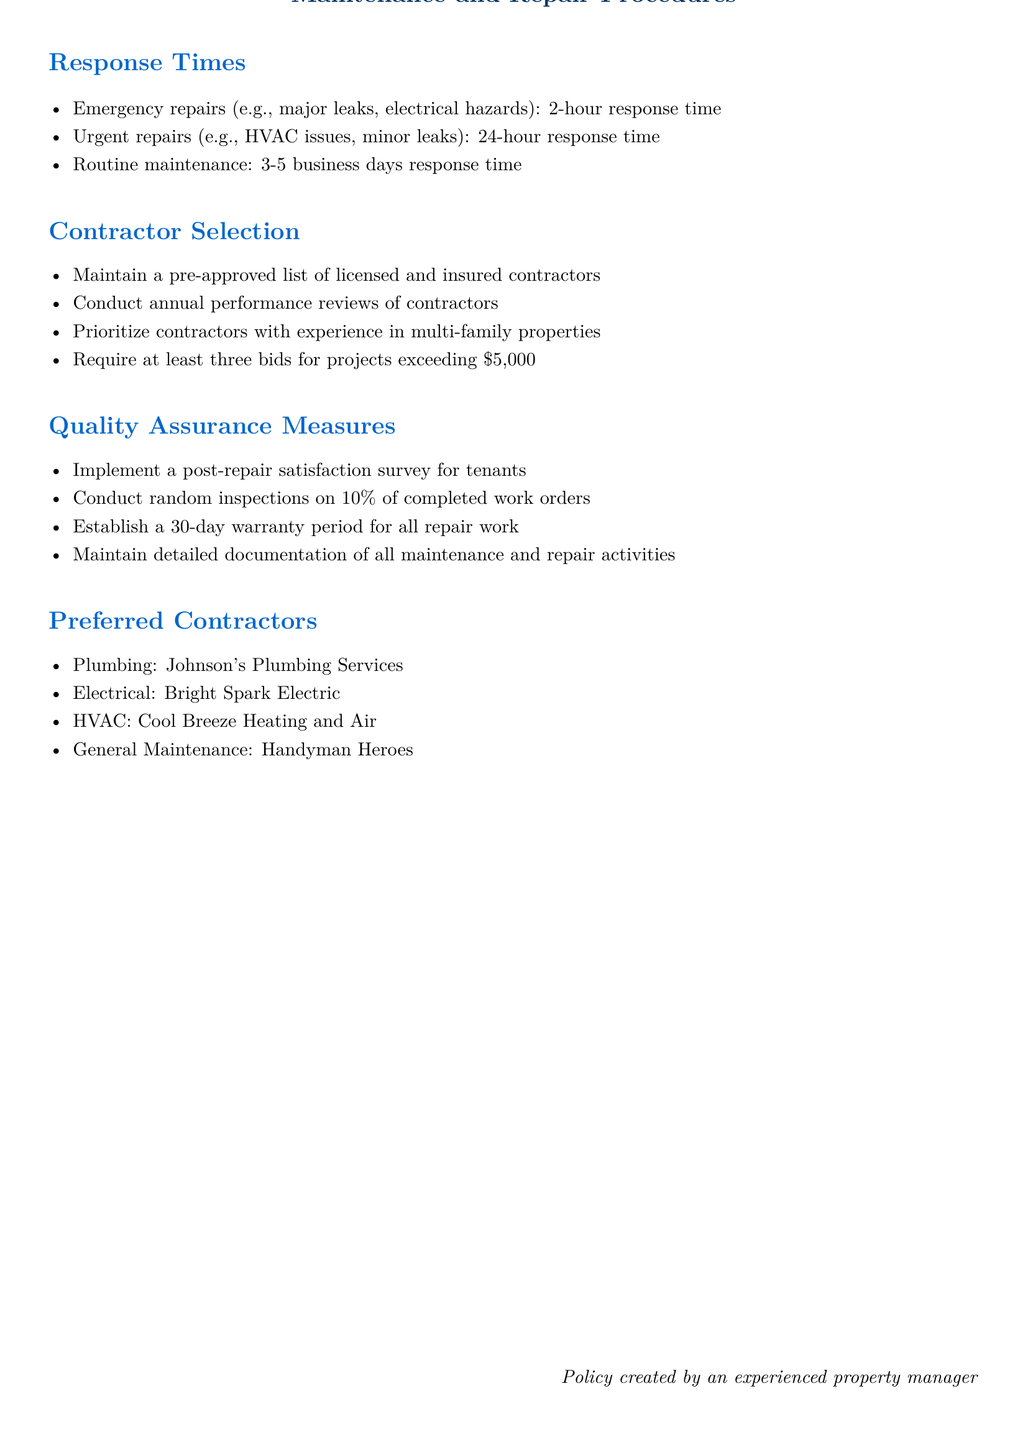What is the response time for emergency repairs? Emergency repairs are listed with a specified 2-hour response time in the document.
Answer: 2-hour What percentage of completed work orders are randomly inspected? The document states that random inspections are conducted on 10% of completed work orders.
Answer: 10% How many bids are required for projects exceeding $5,000? The policy document specifies that at least three bids are required for such projects.
Answer: three What is the warranty period for all repair work? The document states that a 30-day warranty period is established for all repair work.
Answer: 30-day Which contractor is preferred for electrical work? The document lists Bright Spark Electric as the preferred contractor for electrical services.
Answer: Bright Spark Electric What is the response time for routine maintenance? The document outlines that routine maintenance has a response time of 3-5 business days.
Answer: 3-5 business days What type of contractors are prioritized for selection? The document highlights that contractors with experience in multi-family properties are prioritized for selection.
Answer: multi-family properties What is implemented to measure tenant satisfaction after repairs? A post-repair satisfaction survey for tenants is implemented according to the policy document.
Answer: satisfaction survey Who created the policy document? The document mentions that the policy was created by an experienced property manager.
Answer: an experienced property manager 